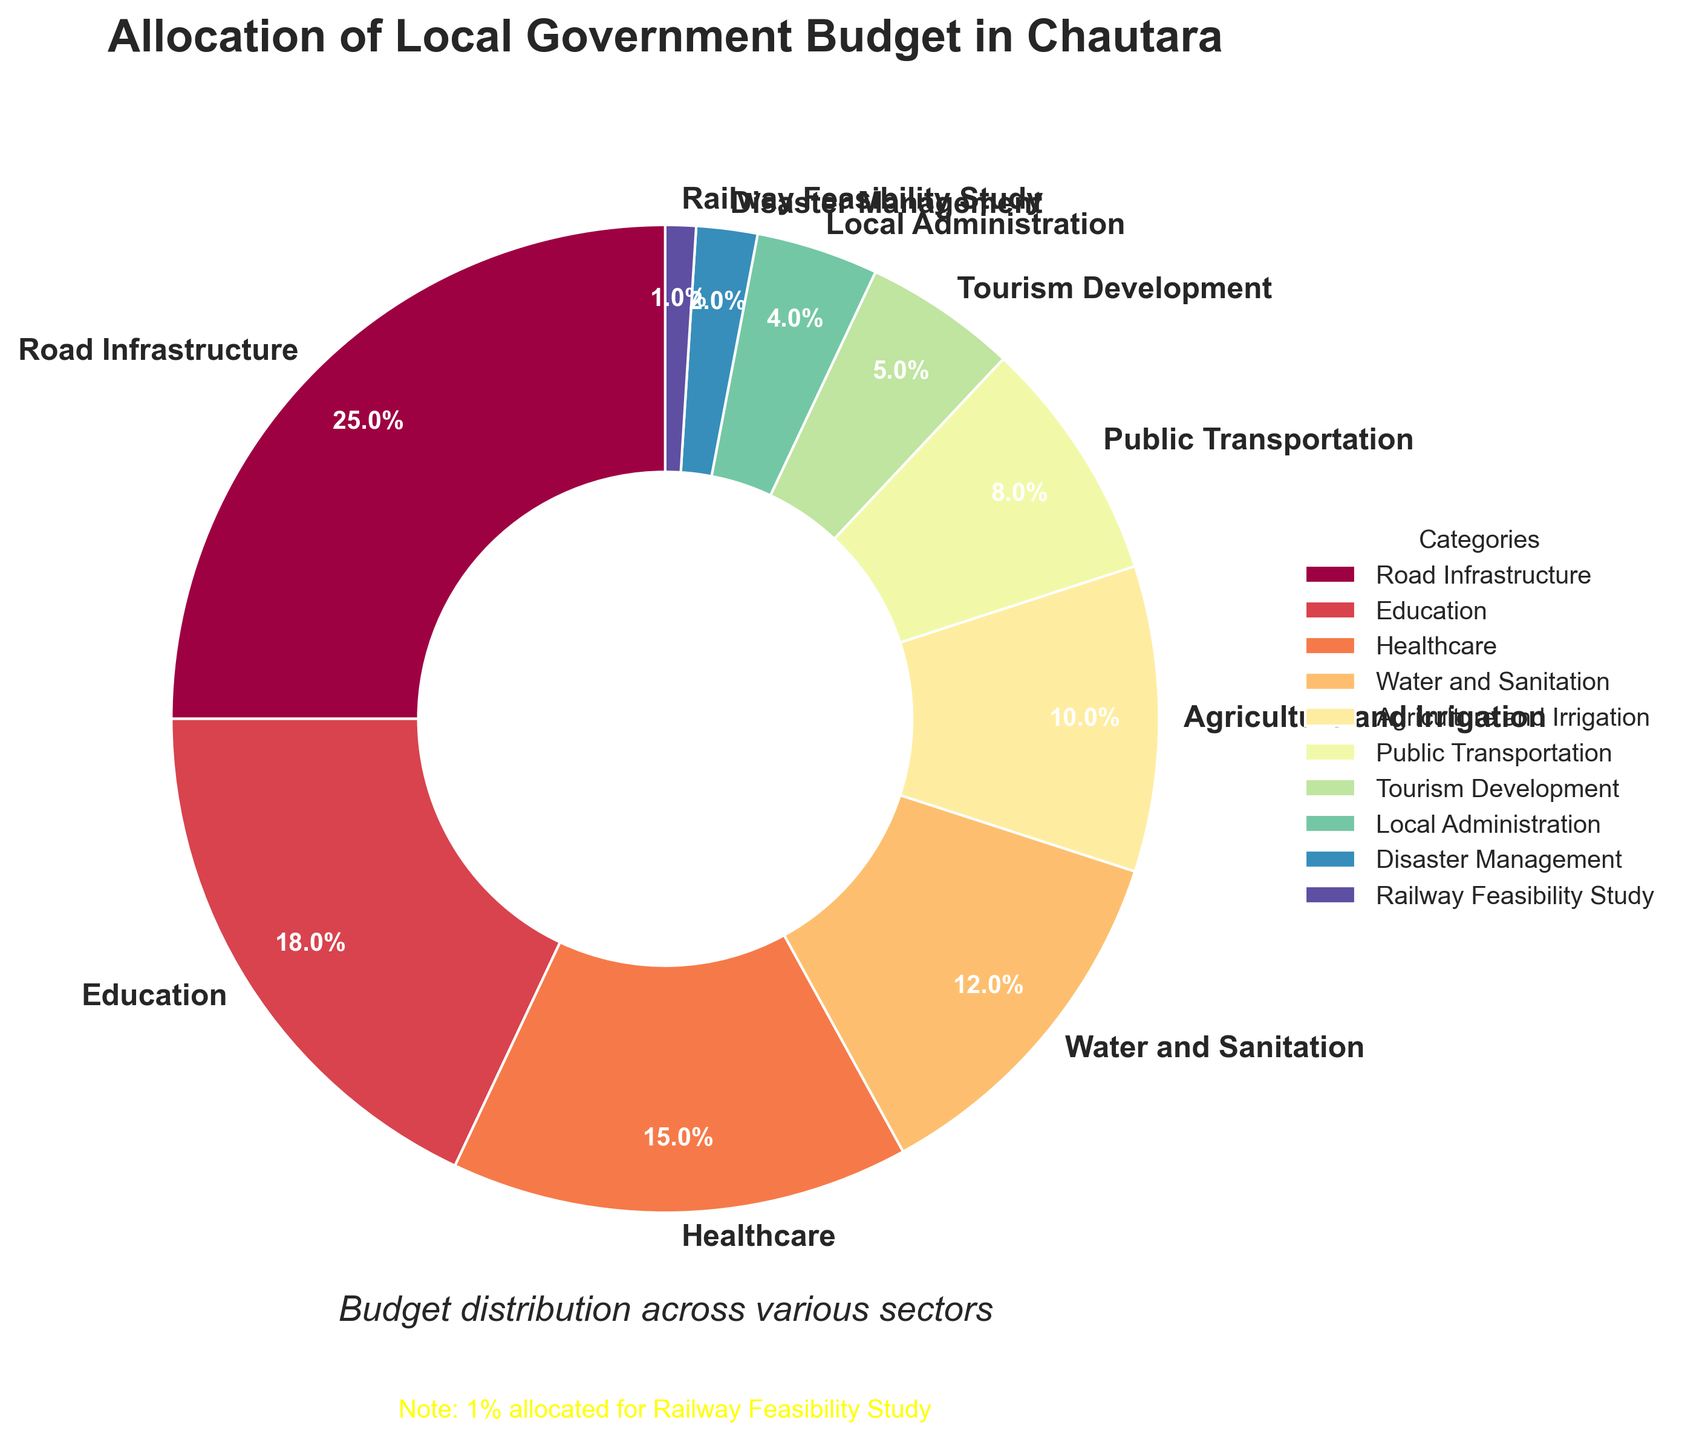What's the total percentage allocated to Road Infrastructure, Education, and Healthcare? To find the total percentage allocated to these three categories, sum their individual allocations: 25% (Road Infrastructure) + 18% (Education) + 15% (Healthcare) = 58%.
Answer: 58% Which category has the smallest budget allocation? The category with the smallest budget allocation can be seen directly from the chart, which is Railway Feasibility Study with 1%.
Answer: Railway Feasibility Study How much more budget is allocated to Road Infrastructure compared to Local Administration? Subtract the percentage allocated to Local Administration from the percentage allocated to Road Infrastructure: 25% (Road Infrastructure) - 4% (Local Administration) = 21%.
Answer: 21% Are there any categories with a budget allocation of less than 5%? If yes, which ones? The categories with less than 5% allocation, as indicated on the chart, are Local Administration (4%), Disaster Management (2%), and Railway Feasibility Study (1%).
Answer: Local Administration, Disaster Management, Railway Feasibility Study What are the combined budget allocations for Agriculture and Irrigation, and Public Transportation? Sum the percentages for Agriculture and Irrigation (10%) with Public Transportation (8%): 10% + 8% = 18%.
Answer: 18% Is the budget for Education higher than that for Healthcare? Compare the percentages: Education is allocated 18% while Healthcare is allocated 15%. Since 18% is greater than 15%, Education has a higher allocation.
Answer: Yes Which two categories combined make up the largest budget allocation? The largest individual allocations are Road Infrastructure (25%) and Education (18%). Combined, they make up 25% + 18% = 43%.
Answer: Road Infrastructure and Education By how much does the budget for Public Transportation differ from that for Healthcare? Subtract the percentage of Public Transportation from Healthcare: 15% (Healthcare) - 8% (Public Transportation) = 7%.
Answer: 7% What's the difference in budget allocation between the three sectors with the highest and the lowest allocations combined? Calculate the total of the three highest (Road Infrastructure 25% + Education 18% + Healthcare 15% = 58%) and subtract the total of the three lowest (Local Administration 4% + Disaster Management 2% + Railway Feasibility Study 1% = 7%): 58% - 7% = 51%.
Answer: 51% 